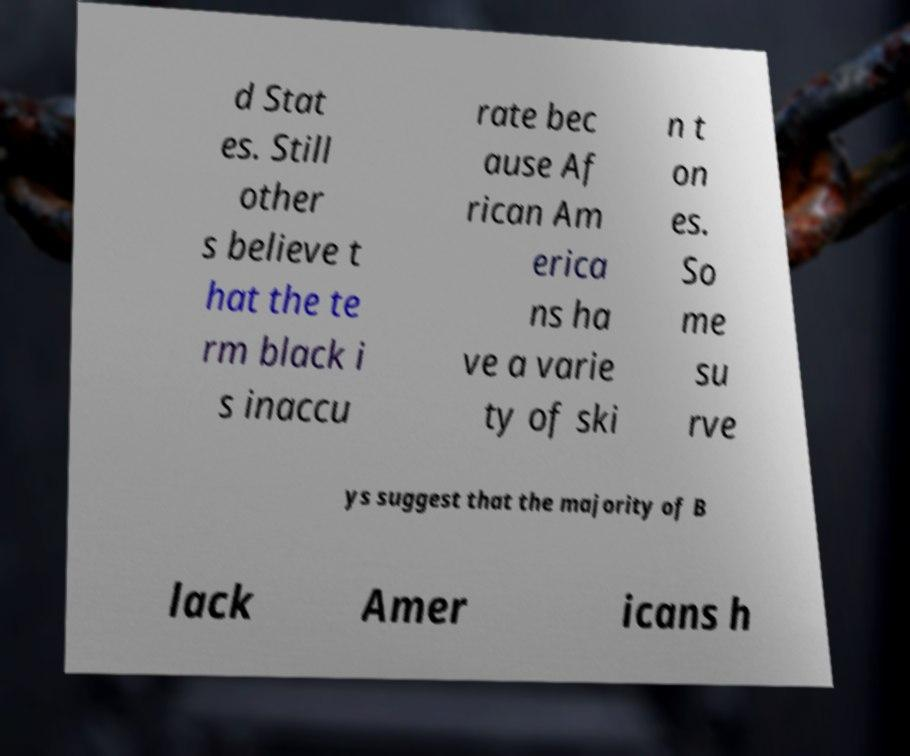I need the written content from this picture converted into text. Can you do that? d Stat es. Still other s believe t hat the te rm black i s inaccu rate bec ause Af rican Am erica ns ha ve a varie ty of ski n t on es. So me su rve ys suggest that the majority of B lack Amer icans h 